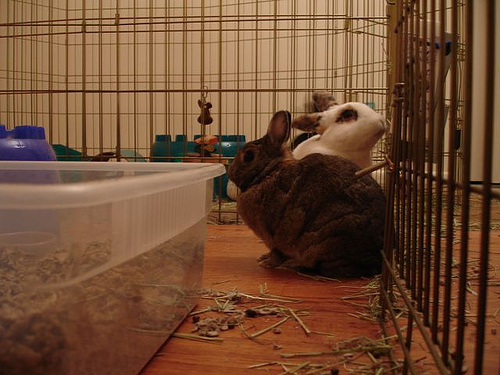<image>
Is there a rabbit in front of the fence? No. The rabbit is not in front of the fence. The spatial positioning shows a different relationship between these objects. Is the mouse in front of the rabbit? No. The mouse is not in front of the rabbit. The spatial positioning shows a different relationship between these objects. 